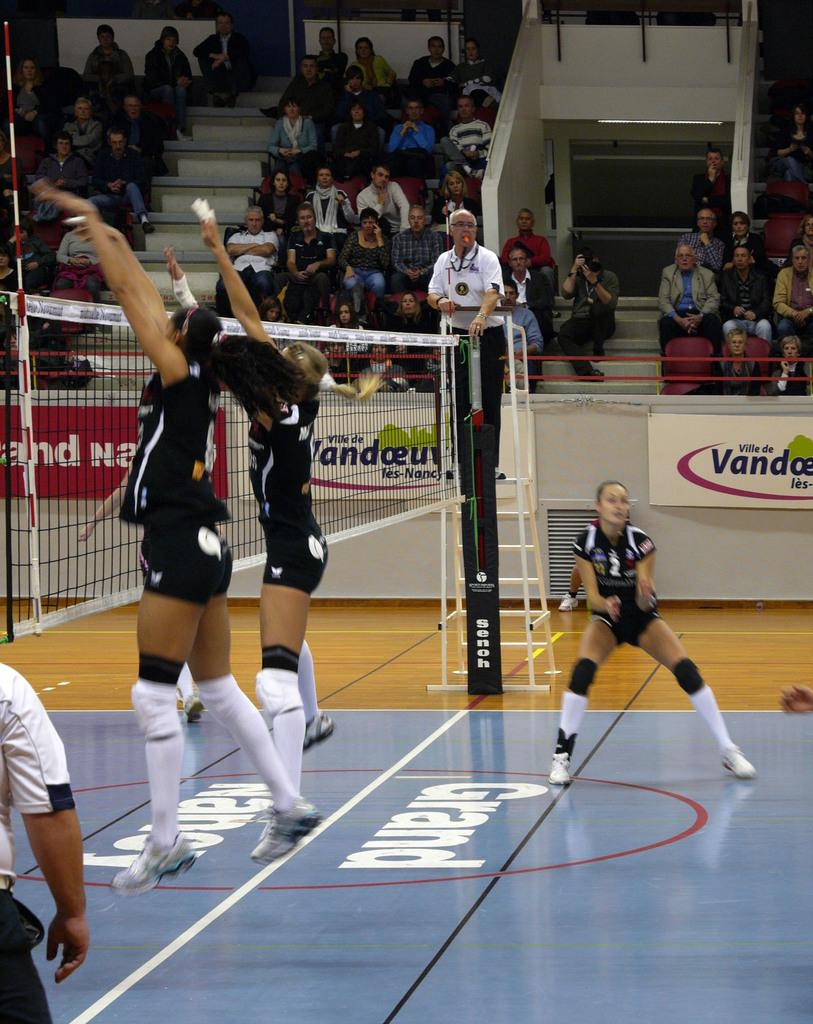<image>
Create a compact narrative representing the image presented. Grand Nand and Ville de sponsors the volleyball game. 